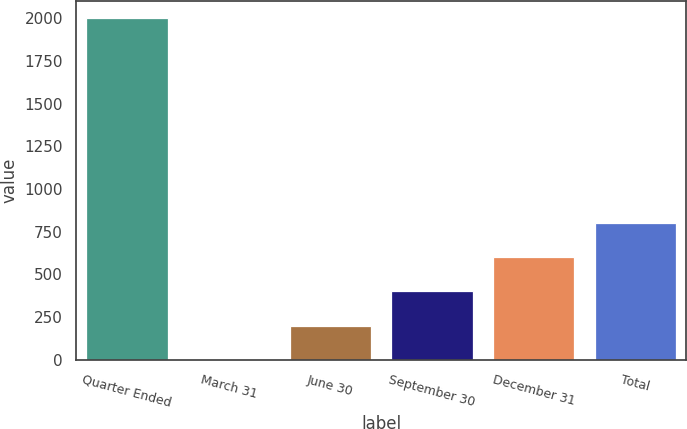Convert chart to OTSL. <chart><loc_0><loc_0><loc_500><loc_500><bar_chart><fcel>Quarter Ended<fcel>March 31<fcel>June 30<fcel>September 30<fcel>December 31<fcel>Total<nl><fcel>2002<fcel>0.18<fcel>200.36<fcel>400.54<fcel>600.72<fcel>800.9<nl></chart> 